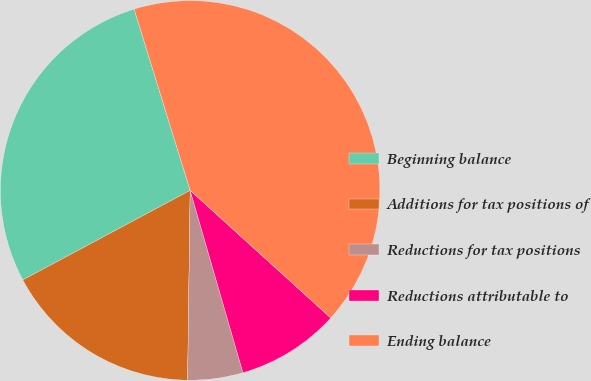<chart> <loc_0><loc_0><loc_500><loc_500><pie_chart><fcel>Beginning balance<fcel>Additions for tax positions of<fcel>Reductions for tax positions<fcel>Reductions attributable to<fcel>Ending balance<nl><fcel>28.05%<fcel>16.97%<fcel>4.7%<fcel>8.79%<fcel>41.5%<nl></chart> 